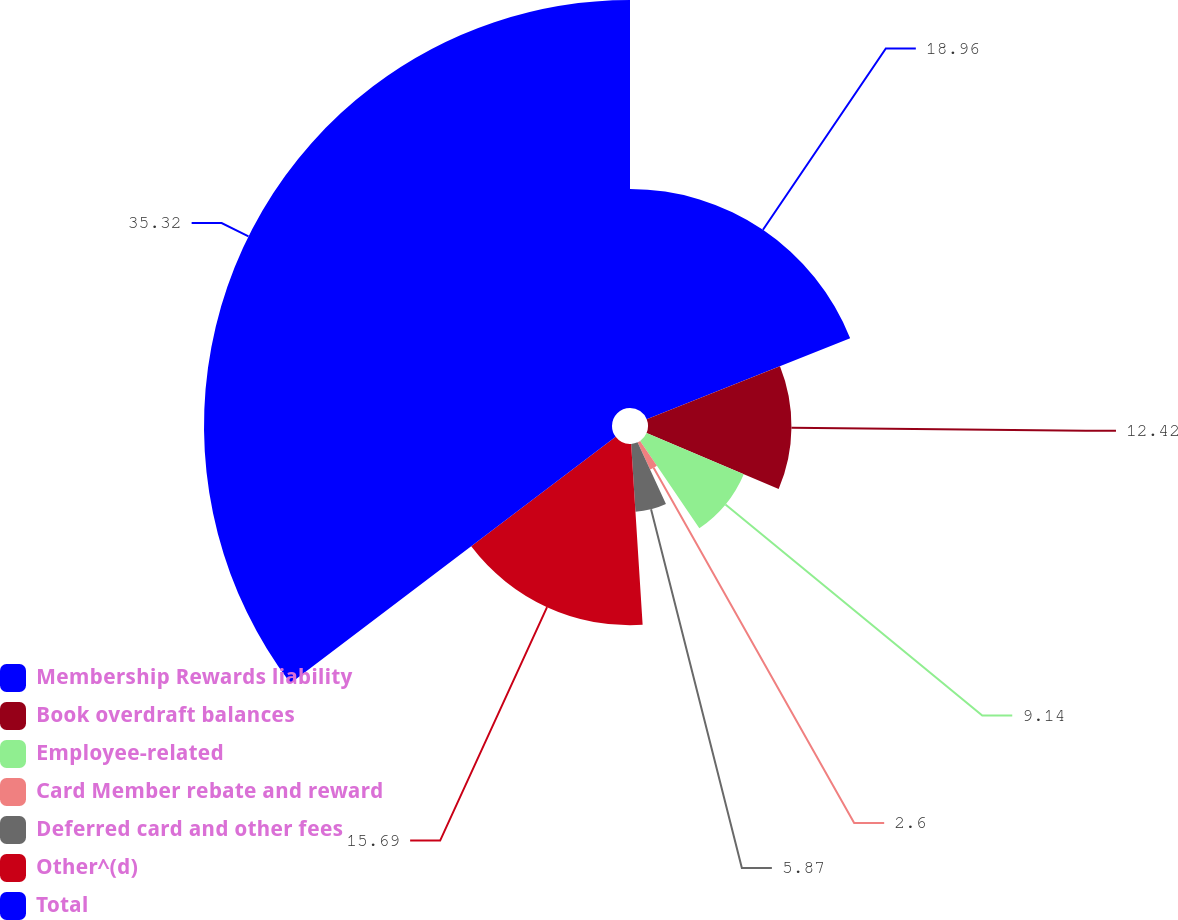<chart> <loc_0><loc_0><loc_500><loc_500><pie_chart><fcel>Membership Rewards liability<fcel>Book overdraft balances<fcel>Employee-related<fcel>Card Member rebate and reward<fcel>Deferred card and other fees<fcel>Other^(d)<fcel>Total<nl><fcel>18.96%<fcel>12.42%<fcel>9.14%<fcel>2.6%<fcel>5.87%<fcel>15.69%<fcel>35.32%<nl></chart> 